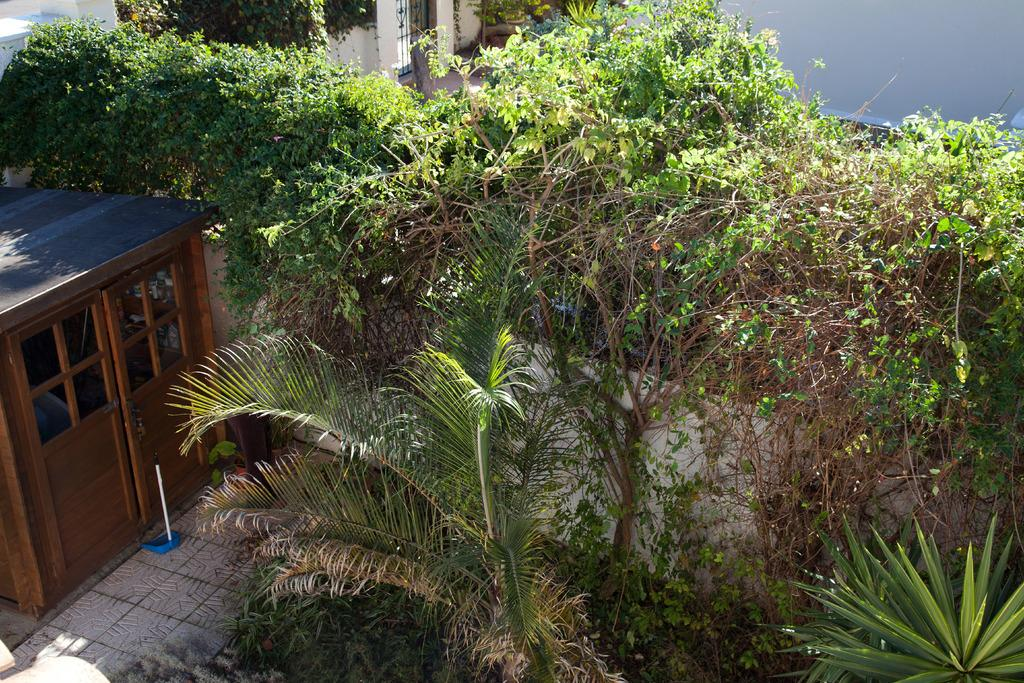What is the primary subject of the image? The primary subject of the image is the many plants. Can you describe the surrounding area of the plants? There is a small room beside the plants and a door on the other side of the plants. What type of rice is being served in the image? There is no rice present in the image; it features many plants, a small room, and a door. How many lawyers are visible in the image? There are no lawyers present in the image; it features many plants, a small room, and a door. 